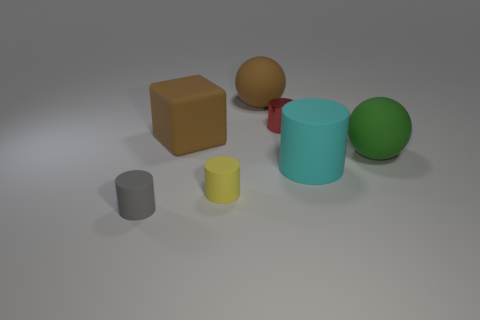There is a thing that is the same color as the block; what size is it?
Offer a terse response. Large. There is a large rubber object that is the same color as the matte cube; what is its shape?
Provide a succinct answer. Sphere. There is a shiny thing that is the same shape as the tiny yellow matte object; what is its color?
Your answer should be compact. Red. Are there any other things that are the same color as the cube?
Ensure brevity in your answer.  Yes. What number of matte objects are either gray objects or big cyan things?
Keep it short and to the point. 2. Is the color of the large cylinder the same as the cube?
Provide a short and direct response. No. Is the number of small things that are behind the small red metal object greater than the number of brown metal cubes?
Make the answer very short. No. What number of other objects are the same material as the tiny yellow object?
Offer a very short reply. 5. How many small objects are either red matte cylinders or rubber cubes?
Your answer should be compact. 0. Is the red cylinder made of the same material as the green sphere?
Provide a short and direct response. No. 